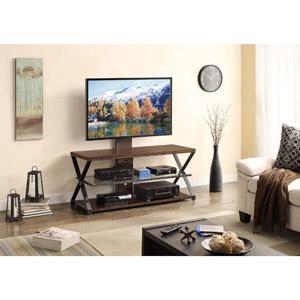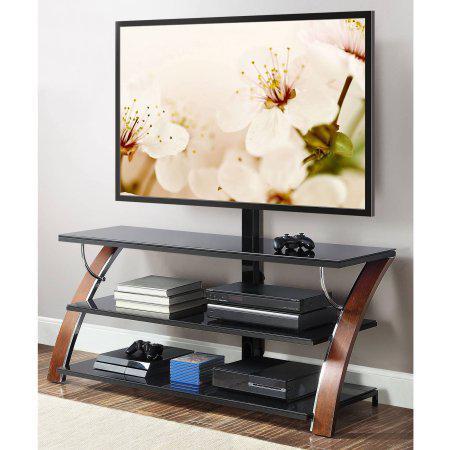The first image is the image on the left, the second image is the image on the right. Considering the images on both sides, is "Both TV stands have three shelves." valid? Answer yes or no. Yes. The first image is the image on the left, the second image is the image on the right. Analyze the images presented: Is the assertion "The right image features a TV stand with Z-shaped ends formed by a curved diagonal piece, and the left image features a stand with at least one X-shape per end." valid? Answer yes or no. Yes. 